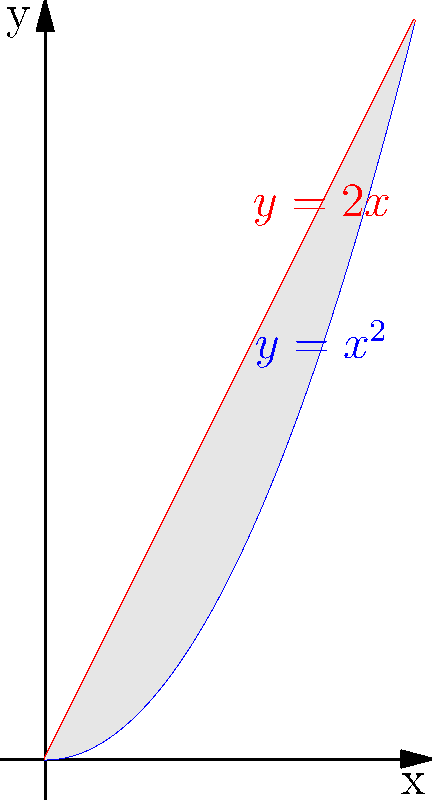In the context of public resource allocation, consider a project where the benefit ($y$) is modeled by two functions: $y=x^2$ (blue curve) and $y=2x$ (red line), where $x$ represents the investment in crores of rupees. Calculate the area of the shaded region bounded by these two curves. This area represents the potential economic impact of choosing between two different investment strategies. How would you interpret this result in terms of public policy decision-making? To find the area of the region bounded by $y=x^2$ and $y=2x$, we follow these steps:

1) Find the points of intersection:
   Set $x^2 = 2x$
   $x^2 - 2x = 0$
   $x(x - 2) = 0$
   $x = 0$ or $x = 2$

2) Set up the integral:
   Area = $\int_{0}^{2} (2x - x^2) dx$

3) Evaluate the integral:
   $\int_{0}^{2} (2x - x^2) dx = [x^2 - \frac{x^3}{3}]_{0}^{2}$
   
   $= (4 - \frac{8}{3}) - (0 - 0)$
   
   $= \frac{12}{3} - \frac{8}{3} = \frac{4}{3}$

4) Interpret the result:
   The area of $\frac{4}{3}$ square units represents the difference in cumulative benefits between the two investment strategies over the range of 0 to 2 crore rupees. In public policy terms, this suggests that one strategy (represented by $y=2x$) offers more overall benefit up to the 2 crore mark, but the other strategy ($y=x^2$) starts to yield higher returns beyond this point.
Answer: $\frac{4}{3}$ square units; represents differential benefit between linear and quadratic investment strategies. 